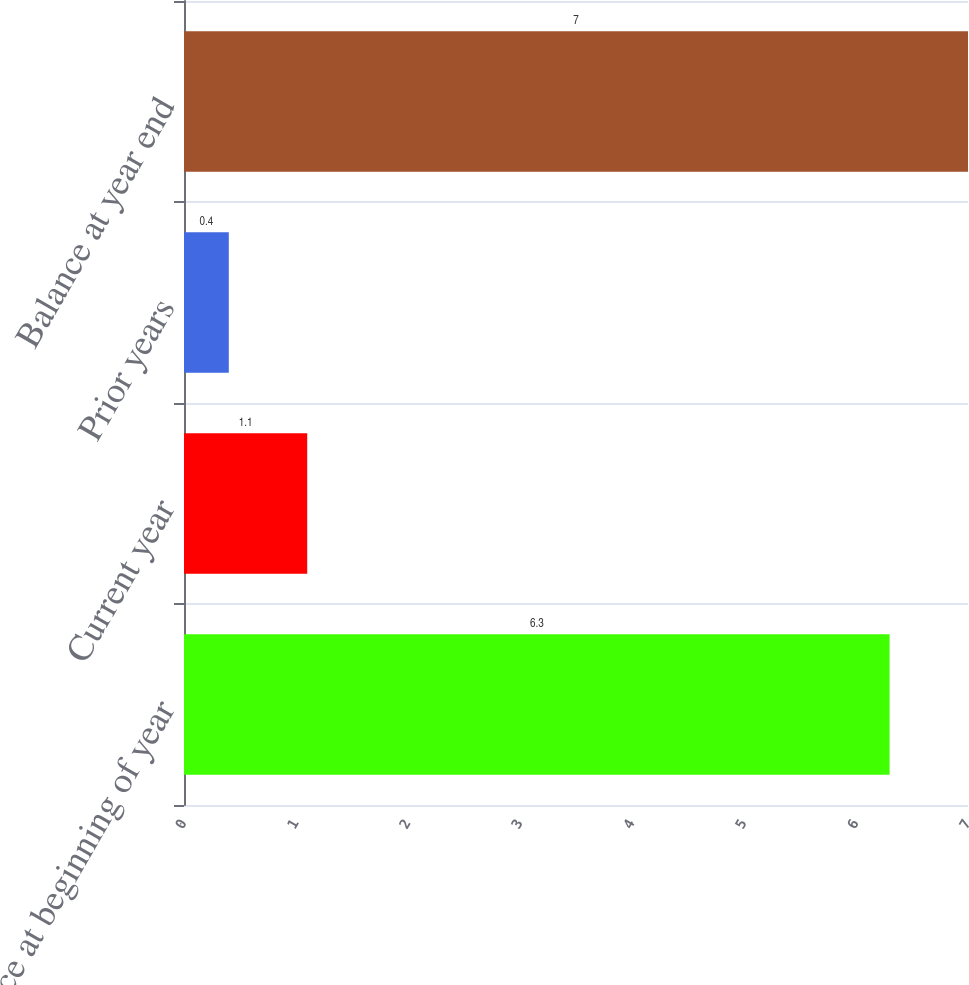Convert chart. <chart><loc_0><loc_0><loc_500><loc_500><bar_chart><fcel>Balance at beginning of year<fcel>Current year<fcel>Prior years<fcel>Balance at year end<nl><fcel>6.3<fcel>1.1<fcel>0.4<fcel>7<nl></chart> 